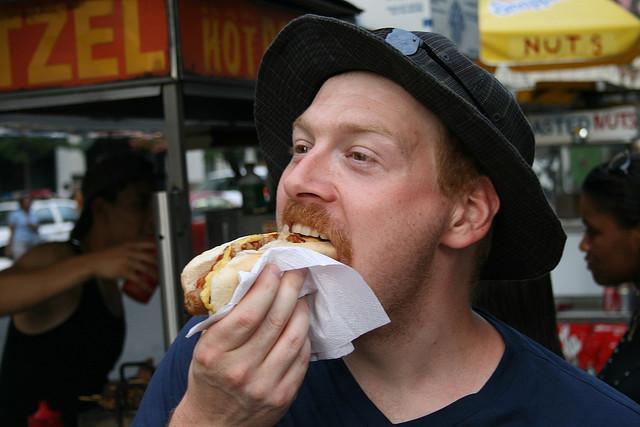How many people can be seen?
Give a very brief answer. 3. 